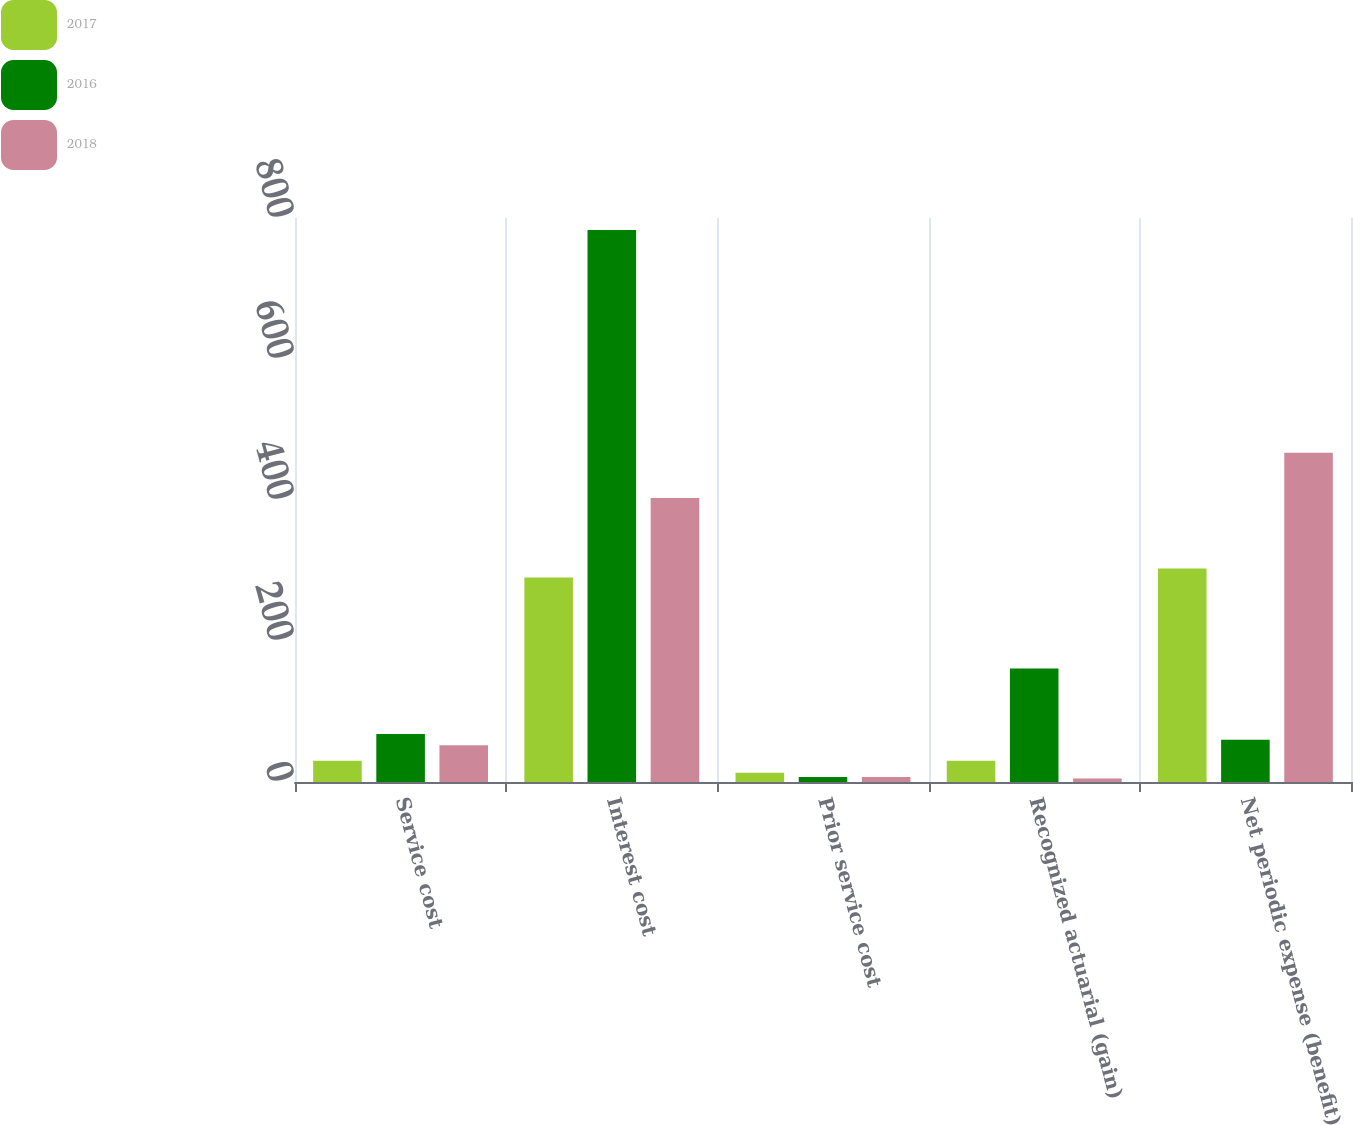Convert chart to OTSL. <chart><loc_0><loc_0><loc_500><loc_500><stacked_bar_chart><ecel><fcel>Service cost<fcel>Interest cost<fcel>Prior service cost<fcel>Recognized actuarial (gain)<fcel>Net periodic expense (benefit)<nl><fcel>2017<fcel>30<fcel>290<fcel>13<fcel>30<fcel>303<nl><fcel>2016<fcel>68<fcel>783<fcel>7<fcel>161<fcel>60<nl><fcel>2018<fcel>52<fcel>403<fcel>7<fcel>5<fcel>467<nl></chart> 